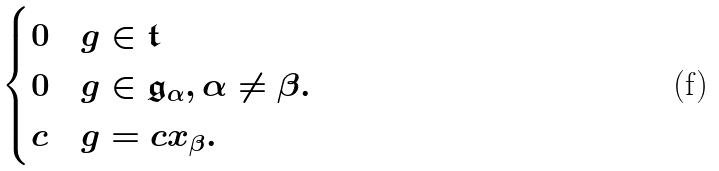Convert formula to latex. <formula><loc_0><loc_0><loc_500><loc_500>\begin{cases} 0 & g \in \mathfrak { t } \\ 0 & g \in \mathfrak { g } _ { \alpha } , \alpha \neq \beta . \\ c & g = c x _ { \beta } . \end{cases}</formula> 